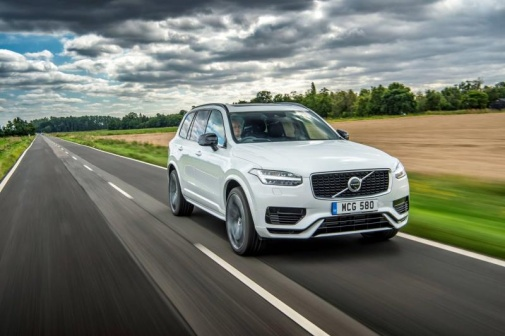What can you infer about the weather from the image? The image suggests that the weather was rainy recently, as indicated by the wet road surface. The presence of thick clouds in the sky implies that it might be overcast or that more rain could be on the way. The overall light condition seems soft, which is typical on cloudy days, enhancing the lushness of the green fields and trees. 